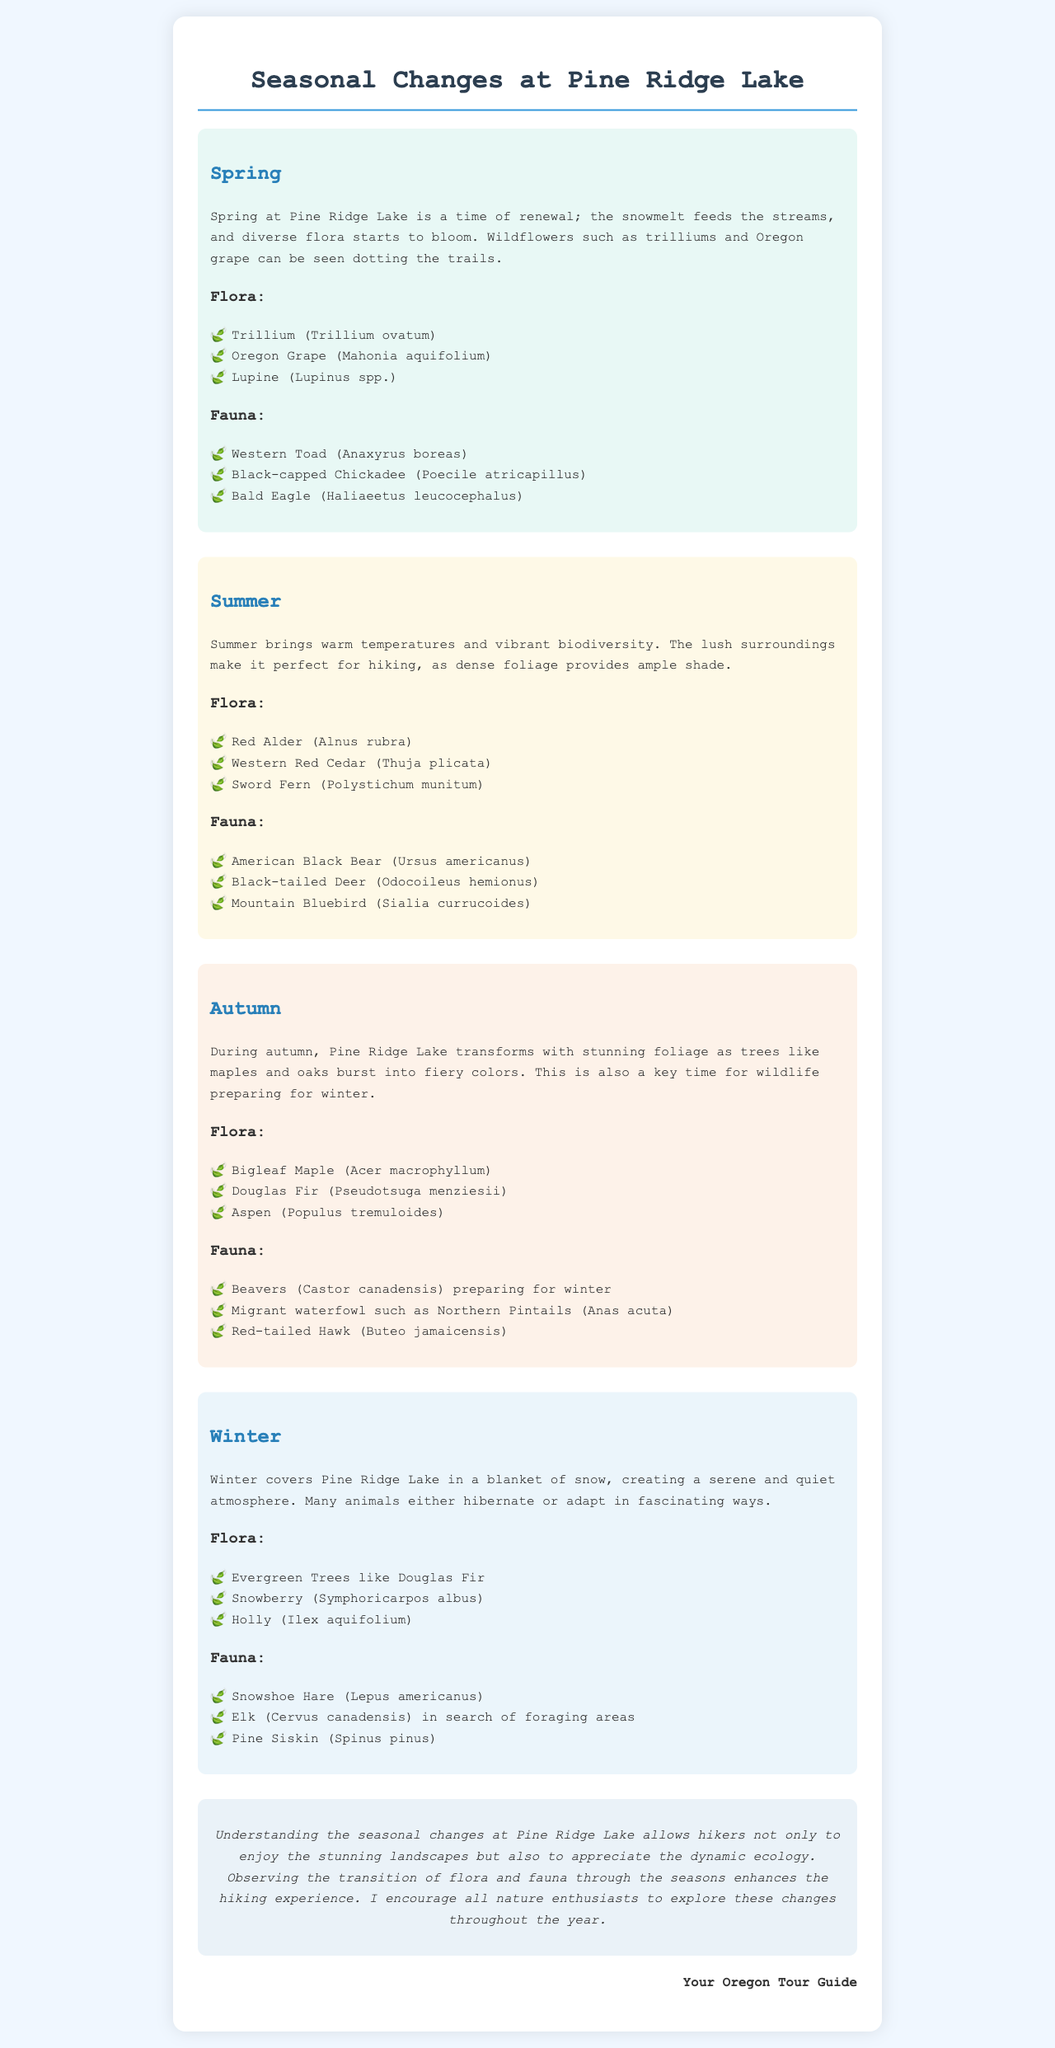What flora can be found in spring? The spring section lists wildflowers such as trilliums, Oregon grape, and lupine.
Answer: Trillium, Oregon Grape, Lupine Which animal prepares for winter in autumn? The autumn section mentions beavers preparing for winter among other fauna.
Answer: Beavers What type of tree is predominant in winter? The winter section mentions evergreen trees like Douglas Fir as prominent flora during winter.
Answer: Evergreen Trees How does summer affect hiking conditions? The summer section explains warm temperatures and dense foliage provide ample shade for hikers.
Answer: Ample shade What is a key characteristic of winter at Pine Ridge Lake? The winter section describes the atmosphere as serene and quiet due to the blanket of snow.
Answer: Serene and quiet Which bird can be observed in spring? The spring section lists the black-capped chickadee as a fauna example in that season.
Answer: Black-capped Chickadee What color changes can be observed in autumn? The autumn section highlights the stunning foliage with fiery colors of trees like maples and oaks.
Answer: Fiery colors What is the overall theme of the document? The document addresses seasonal changes and their impacts on flora and fauna at Pine Ridge Lake.
Answer: Seasonal changes What is encouraged for nature enthusiasts? The conclusion suggests exploring the seasonal changes throughout the year.
Answer: Explore these changes 